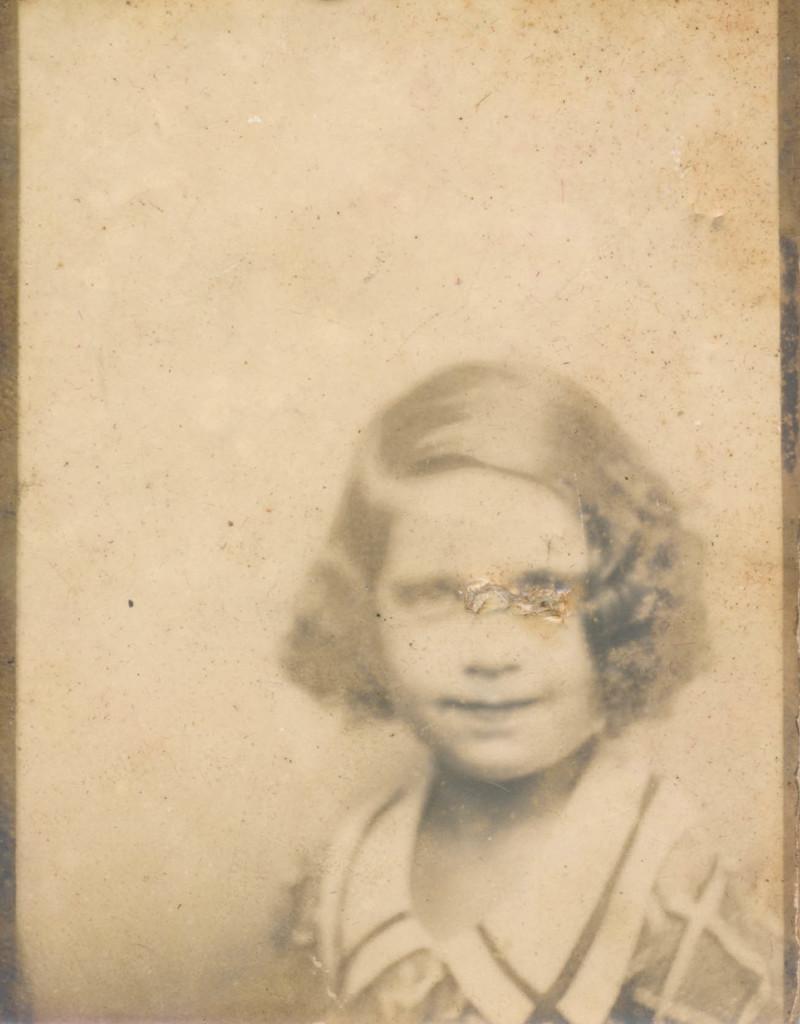Can you describe this image briefly? In this image we can see a black and white picture of a girl. 